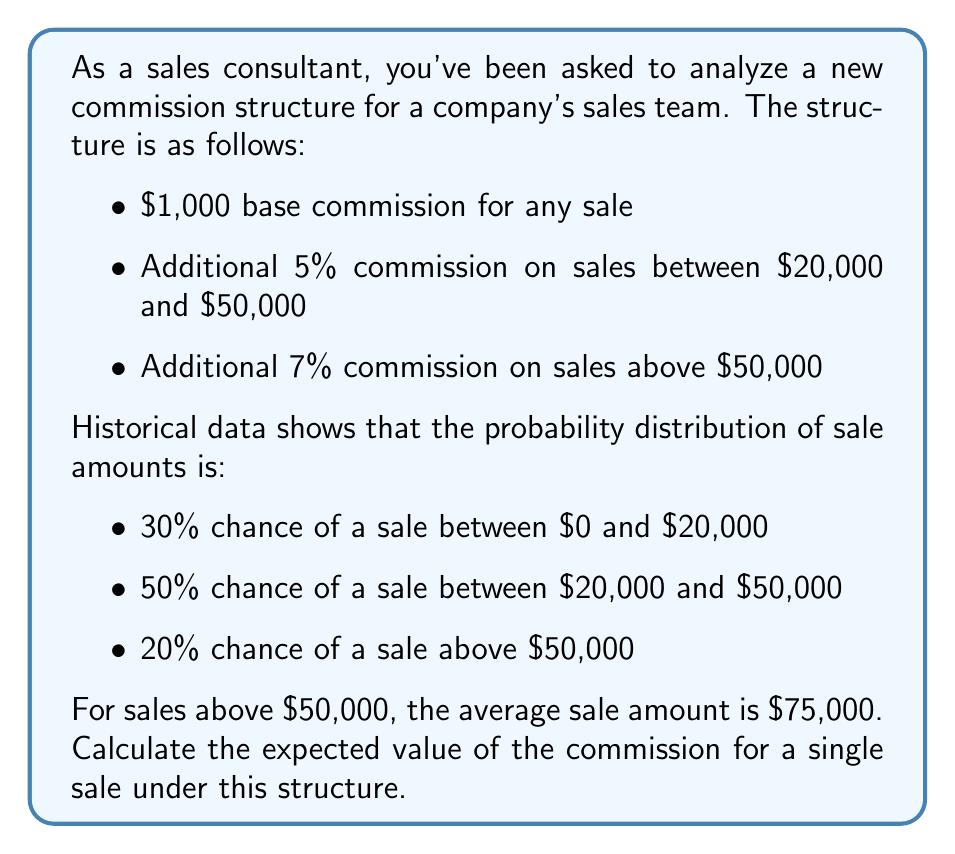Provide a solution to this math problem. To calculate the expected value of the commission, we need to consider each possible outcome and its associated probability. Let's break it down step by step:

1. For sales between $0 and $20,000:
   - Probability: 30% = 0.3
   - Commission: $1,000 (base only)
   - Expected value for this range: $1,000 * 0.3 = $300

2. For sales between $20,000 and $50,000:
   - Probability: 50% = 0.5
   - Commission: $1,000 (base) + 5% of (average sale amount - $20,000)
   - Average sale amount in this range: $(20,000 + 50,000) / 2 = $35,000
   - Commission = $1,000 + 0.05 * ($35,000 - $20,000) = $1,000 + $750 = $1,750
   - Expected value for this range: $1,750 * 0.5 = $875

3. For sales above $50,000:
   - Probability: 20% = 0.2
   - Average sale amount: $75,000
   - Commission: $1,000 (base) + 5% of ($50,000 - $20,000) + 7% of ($75,000 - $50,000)
   - Commission = $1,000 + 0.05 * $30,000 + 0.07 * $25,000 = $1,000 + $1,500 + $1,750 = $4,250
   - Expected value for this range: $4,250 * 0.2 = $850

Now, we sum up the expected values from each range to get the total expected value:

$$E(\text{Commission}) = 300 + 875 + 850 = \$2,025$$
Answer: $2,025 